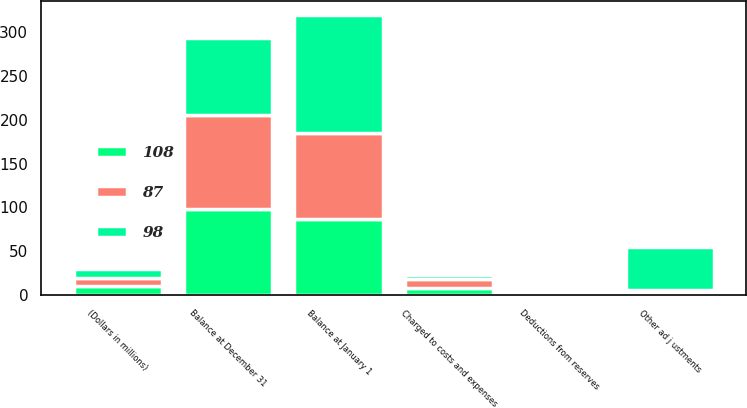<chart> <loc_0><loc_0><loc_500><loc_500><stacked_bar_chart><ecel><fcel>(Dollars in millions)<fcel>Balance at January 1<fcel>Charged to costs and expenses<fcel>Deductions from reserves<fcel>Other ad j ustments<fcel>Balance at December 31<nl><fcel>87<fcel>10<fcel>98<fcel>10<fcel>2<fcel>2<fcel>108<nl><fcel>108<fcel>10<fcel>87<fcel>8<fcel>1<fcel>4<fcel>98<nl><fcel>98<fcel>10<fcel>135<fcel>5<fcel>4<fcel>49<fcel>87<nl></chart> 